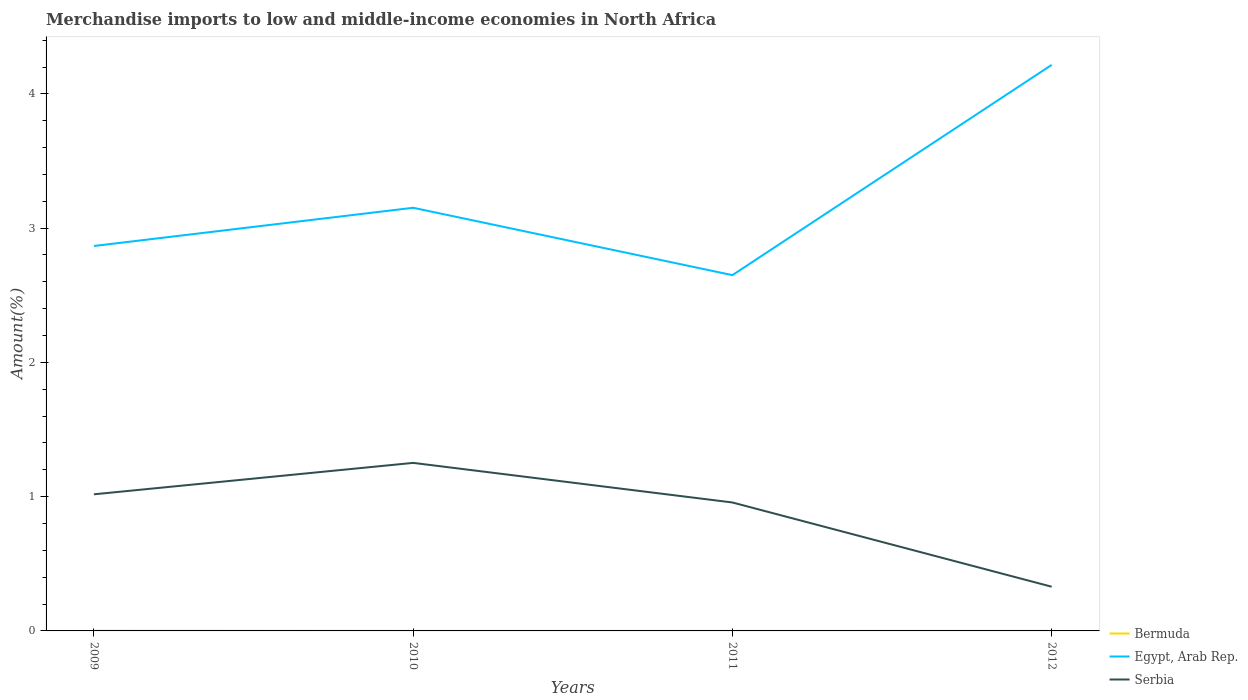Does the line corresponding to Egypt, Arab Rep. intersect with the line corresponding to Bermuda?
Make the answer very short. No. Is the number of lines equal to the number of legend labels?
Keep it short and to the point. Yes. Across all years, what is the maximum percentage of amount earned from merchandise imports in Bermuda?
Your answer should be very brief. 0. What is the total percentage of amount earned from merchandise imports in Egypt, Arab Rep. in the graph?
Provide a succinct answer. -1.06. What is the difference between the highest and the second highest percentage of amount earned from merchandise imports in Egypt, Arab Rep.?
Ensure brevity in your answer.  1.57. Is the percentage of amount earned from merchandise imports in Bermuda strictly greater than the percentage of amount earned from merchandise imports in Egypt, Arab Rep. over the years?
Keep it short and to the point. Yes. How many years are there in the graph?
Offer a terse response. 4. What is the difference between two consecutive major ticks on the Y-axis?
Offer a very short reply. 1. Are the values on the major ticks of Y-axis written in scientific E-notation?
Ensure brevity in your answer.  No. Does the graph contain grids?
Your answer should be compact. No. Where does the legend appear in the graph?
Give a very brief answer. Bottom right. What is the title of the graph?
Your answer should be compact. Merchandise imports to low and middle-income economies in North Africa. Does "Sudan" appear as one of the legend labels in the graph?
Keep it short and to the point. No. What is the label or title of the Y-axis?
Your response must be concise. Amount(%). What is the Amount(%) of Bermuda in 2009?
Offer a very short reply. 0. What is the Amount(%) in Egypt, Arab Rep. in 2009?
Keep it short and to the point. 2.87. What is the Amount(%) of Serbia in 2009?
Provide a succinct answer. 1.02. What is the Amount(%) in Bermuda in 2010?
Make the answer very short. 0. What is the Amount(%) in Egypt, Arab Rep. in 2010?
Offer a terse response. 3.15. What is the Amount(%) in Serbia in 2010?
Offer a terse response. 1.25. What is the Amount(%) in Bermuda in 2011?
Provide a short and direct response. 0. What is the Amount(%) in Egypt, Arab Rep. in 2011?
Keep it short and to the point. 2.65. What is the Amount(%) in Serbia in 2011?
Give a very brief answer. 0.96. What is the Amount(%) in Bermuda in 2012?
Make the answer very short. 0. What is the Amount(%) in Egypt, Arab Rep. in 2012?
Make the answer very short. 4.22. What is the Amount(%) of Serbia in 2012?
Provide a succinct answer. 0.33. Across all years, what is the maximum Amount(%) of Bermuda?
Keep it short and to the point. 0. Across all years, what is the maximum Amount(%) of Egypt, Arab Rep.?
Keep it short and to the point. 4.22. Across all years, what is the maximum Amount(%) of Serbia?
Keep it short and to the point. 1.25. Across all years, what is the minimum Amount(%) in Bermuda?
Make the answer very short. 0. Across all years, what is the minimum Amount(%) in Egypt, Arab Rep.?
Provide a short and direct response. 2.65. Across all years, what is the minimum Amount(%) of Serbia?
Make the answer very short. 0.33. What is the total Amount(%) in Bermuda in the graph?
Give a very brief answer. 0. What is the total Amount(%) of Egypt, Arab Rep. in the graph?
Provide a succinct answer. 12.88. What is the total Amount(%) in Serbia in the graph?
Give a very brief answer. 3.56. What is the difference between the Amount(%) of Bermuda in 2009 and that in 2010?
Your response must be concise. 0. What is the difference between the Amount(%) of Egypt, Arab Rep. in 2009 and that in 2010?
Give a very brief answer. -0.28. What is the difference between the Amount(%) of Serbia in 2009 and that in 2010?
Offer a very short reply. -0.23. What is the difference between the Amount(%) of Bermuda in 2009 and that in 2011?
Your answer should be compact. 0. What is the difference between the Amount(%) in Egypt, Arab Rep. in 2009 and that in 2011?
Keep it short and to the point. 0.22. What is the difference between the Amount(%) in Serbia in 2009 and that in 2011?
Your response must be concise. 0.06. What is the difference between the Amount(%) in Bermuda in 2009 and that in 2012?
Ensure brevity in your answer.  0. What is the difference between the Amount(%) in Egypt, Arab Rep. in 2009 and that in 2012?
Offer a very short reply. -1.35. What is the difference between the Amount(%) of Serbia in 2009 and that in 2012?
Offer a terse response. 0.69. What is the difference between the Amount(%) in Egypt, Arab Rep. in 2010 and that in 2011?
Your answer should be very brief. 0.5. What is the difference between the Amount(%) of Serbia in 2010 and that in 2011?
Keep it short and to the point. 0.29. What is the difference between the Amount(%) in Bermuda in 2010 and that in 2012?
Your answer should be very brief. -0. What is the difference between the Amount(%) of Egypt, Arab Rep. in 2010 and that in 2012?
Your answer should be compact. -1.06. What is the difference between the Amount(%) in Serbia in 2010 and that in 2012?
Provide a short and direct response. 0.92. What is the difference between the Amount(%) in Bermuda in 2011 and that in 2012?
Make the answer very short. -0. What is the difference between the Amount(%) in Egypt, Arab Rep. in 2011 and that in 2012?
Provide a succinct answer. -1.57. What is the difference between the Amount(%) in Serbia in 2011 and that in 2012?
Keep it short and to the point. 0.63. What is the difference between the Amount(%) in Bermuda in 2009 and the Amount(%) in Egypt, Arab Rep. in 2010?
Ensure brevity in your answer.  -3.15. What is the difference between the Amount(%) in Bermuda in 2009 and the Amount(%) in Serbia in 2010?
Your answer should be very brief. -1.25. What is the difference between the Amount(%) in Egypt, Arab Rep. in 2009 and the Amount(%) in Serbia in 2010?
Your answer should be compact. 1.62. What is the difference between the Amount(%) of Bermuda in 2009 and the Amount(%) of Egypt, Arab Rep. in 2011?
Provide a succinct answer. -2.65. What is the difference between the Amount(%) in Bermuda in 2009 and the Amount(%) in Serbia in 2011?
Keep it short and to the point. -0.95. What is the difference between the Amount(%) of Egypt, Arab Rep. in 2009 and the Amount(%) of Serbia in 2011?
Keep it short and to the point. 1.91. What is the difference between the Amount(%) of Bermuda in 2009 and the Amount(%) of Egypt, Arab Rep. in 2012?
Give a very brief answer. -4.21. What is the difference between the Amount(%) in Bermuda in 2009 and the Amount(%) in Serbia in 2012?
Keep it short and to the point. -0.33. What is the difference between the Amount(%) in Egypt, Arab Rep. in 2009 and the Amount(%) in Serbia in 2012?
Give a very brief answer. 2.54. What is the difference between the Amount(%) in Bermuda in 2010 and the Amount(%) in Egypt, Arab Rep. in 2011?
Offer a terse response. -2.65. What is the difference between the Amount(%) of Bermuda in 2010 and the Amount(%) of Serbia in 2011?
Ensure brevity in your answer.  -0.96. What is the difference between the Amount(%) of Egypt, Arab Rep. in 2010 and the Amount(%) of Serbia in 2011?
Your answer should be compact. 2.19. What is the difference between the Amount(%) of Bermuda in 2010 and the Amount(%) of Egypt, Arab Rep. in 2012?
Make the answer very short. -4.22. What is the difference between the Amount(%) of Bermuda in 2010 and the Amount(%) of Serbia in 2012?
Provide a short and direct response. -0.33. What is the difference between the Amount(%) in Egypt, Arab Rep. in 2010 and the Amount(%) in Serbia in 2012?
Your answer should be very brief. 2.82. What is the difference between the Amount(%) in Bermuda in 2011 and the Amount(%) in Egypt, Arab Rep. in 2012?
Offer a terse response. -4.22. What is the difference between the Amount(%) in Bermuda in 2011 and the Amount(%) in Serbia in 2012?
Your answer should be compact. -0.33. What is the difference between the Amount(%) in Egypt, Arab Rep. in 2011 and the Amount(%) in Serbia in 2012?
Make the answer very short. 2.32. What is the average Amount(%) in Bermuda per year?
Offer a very short reply. 0. What is the average Amount(%) of Egypt, Arab Rep. per year?
Keep it short and to the point. 3.22. What is the average Amount(%) of Serbia per year?
Keep it short and to the point. 0.89. In the year 2009, what is the difference between the Amount(%) of Bermuda and Amount(%) of Egypt, Arab Rep.?
Offer a terse response. -2.87. In the year 2009, what is the difference between the Amount(%) in Bermuda and Amount(%) in Serbia?
Keep it short and to the point. -1.02. In the year 2009, what is the difference between the Amount(%) in Egypt, Arab Rep. and Amount(%) in Serbia?
Give a very brief answer. 1.85. In the year 2010, what is the difference between the Amount(%) of Bermuda and Amount(%) of Egypt, Arab Rep.?
Offer a terse response. -3.15. In the year 2010, what is the difference between the Amount(%) in Bermuda and Amount(%) in Serbia?
Keep it short and to the point. -1.25. In the year 2010, what is the difference between the Amount(%) in Egypt, Arab Rep. and Amount(%) in Serbia?
Offer a terse response. 1.9. In the year 2011, what is the difference between the Amount(%) in Bermuda and Amount(%) in Egypt, Arab Rep.?
Provide a succinct answer. -2.65. In the year 2011, what is the difference between the Amount(%) of Bermuda and Amount(%) of Serbia?
Provide a succinct answer. -0.96. In the year 2011, what is the difference between the Amount(%) in Egypt, Arab Rep. and Amount(%) in Serbia?
Ensure brevity in your answer.  1.69. In the year 2012, what is the difference between the Amount(%) of Bermuda and Amount(%) of Egypt, Arab Rep.?
Provide a succinct answer. -4.22. In the year 2012, what is the difference between the Amount(%) of Bermuda and Amount(%) of Serbia?
Offer a terse response. -0.33. In the year 2012, what is the difference between the Amount(%) in Egypt, Arab Rep. and Amount(%) in Serbia?
Offer a terse response. 3.89. What is the ratio of the Amount(%) of Bermuda in 2009 to that in 2010?
Ensure brevity in your answer.  4.98. What is the ratio of the Amount(%) in Egypt, Arab Rep. in 2009 to that in 2010?
Make the answer very short. 0.91. What is the ratio of the Amount(%) in Serbia in 2009 to that in 2010?
Make the answer very short. 0.81. What is the ratio of the Amount(%) of Bermuda in 2009 to that in 2011?
Provide a succinct answer. 4.53. What is the ratio of the Amount(%) in Egypt, Arab Rep. in 2009 to that in 2011?
Provide a succinct answer. 1.08. What is the ratio of the Amount(%) in Serbia in 2009 to that in 2011?
Give a very brief answer. 1.06. What is the ratio of the Amount(%) of Bermuda in 2009 to that in 2012?
Make the answer very short. 3.36. What is the ratio of the Amount(%) in Egypt, Arab Rep. in 2009 to that in 2012?
Make the answer very short. 0.68. What is the ratio of the Amount(%) in Serbia in 2009 to that in 2012?
Make the answer very short. 3.09. What is the ratio of the Amount(%) in Bermuda in 2010 to that in 2011?
Ensure brevity in your answer.  0.91. What is the ratio of the Amount(%) in Egypt, Arab Rep. in 2010 to that in 2011?
Offer a terse response. 1.19. What is the ratio of the Amount(%) in Serbia in 2010 to that in 2011?
Provide a succinct answer. 1.31. What is the ratio of the Amount(%) in Bermuda in 2010 to that in 2012?
Make the answer very short. 0.68. What is the ratio of the Amount(%) in Egypt, Arab Rep. in 2010 to that in 2012?
Offer a terse response. 0.75. What is the ratio of the Amount(%) in Serbia in 2010 to that in 2012?
Keep it short and to the point. 3.8. What is the ratio of the Amount(%) in Bermuda in 2011 to that in 2012?
Provide a short and direct response. 0.74. What is the ratio of the Amount(%) in Egypt, Arab Rep. in 2011 to that in 2012?
Give a very brief answer. 0.63. What is the ratio of the Amount(%) of Serbia in 2011 to that in 2012?
Provide a succinct answer. 2.91. What is the difference between the highest and the second highest Amount(%) in Bermuda?
Provide a short and direct response. 0. What is the difference between the highest and the second highest Amount(%) in Egypt, Arab Rep.?
Keep it short and to the point. 1.06. What is the difference between the highest and the second highest Amount(%) in Serbia?
Your answer should be compact. 0.23. What is the difference between the highest and the lowest Amount(%) of Bermuda?
Make the answer very short. 0. What is the difference between the highest and the lowest Amount(%) in Egypt, Arab Rep.?
Your answer should be very brief. 1.57. What is the difference between the highest and the lowest Amount(%) of Serbia?
Your answer should be very brief. 0.92. 